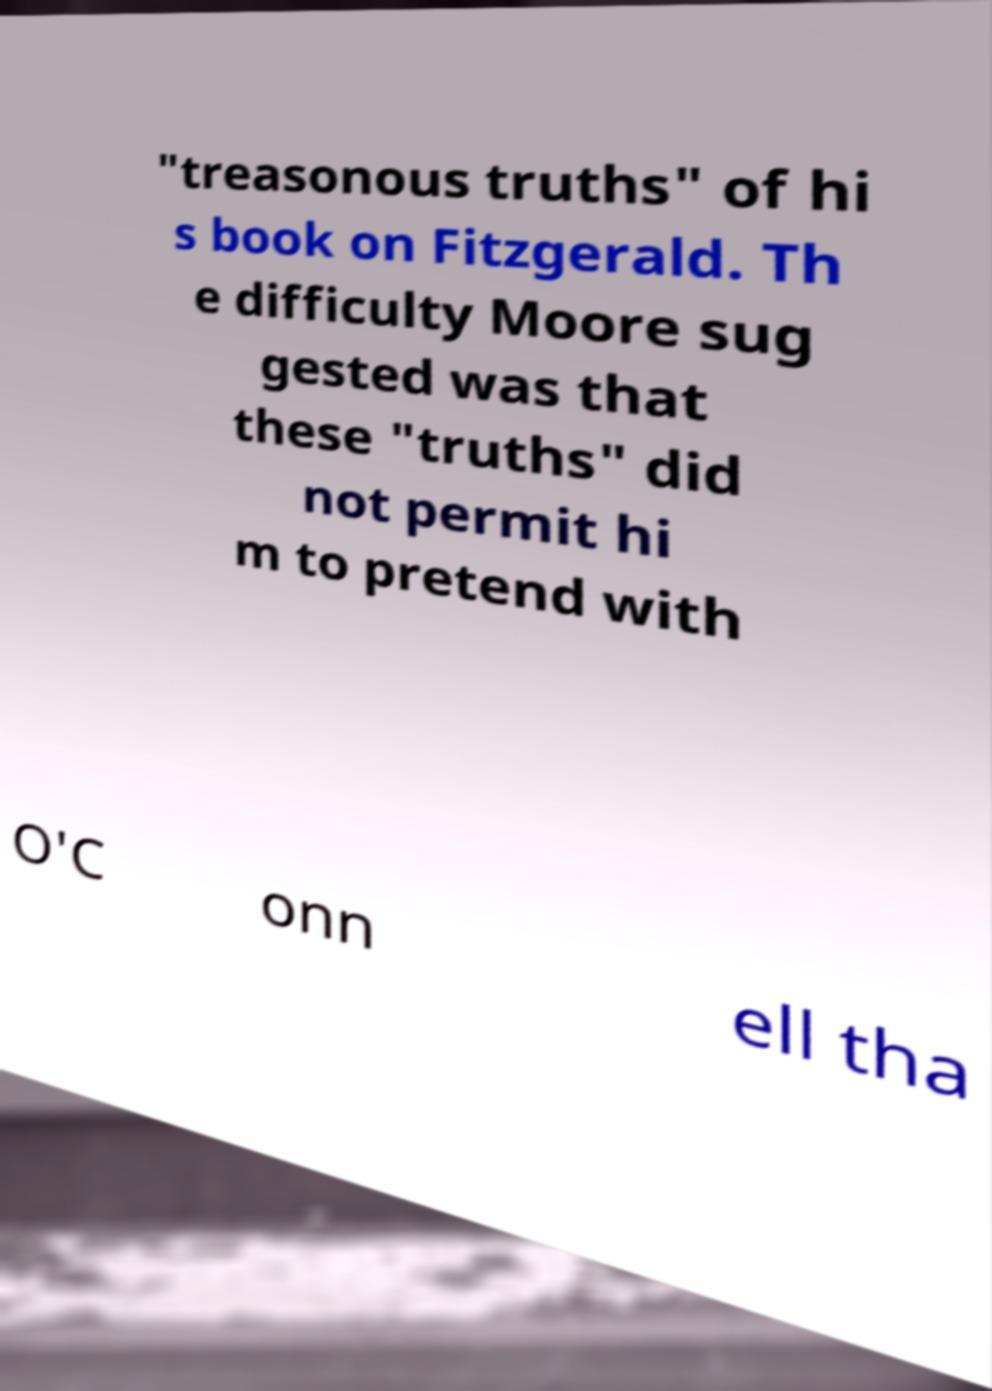I need the written content from this picture converted into text. Can you do that? "treasonous truths" of hi s book on Fitzgerald. Th e difficulty Moore sug gested was that these "truths" did not permit hi m to pretend with O'C onn ell tha 